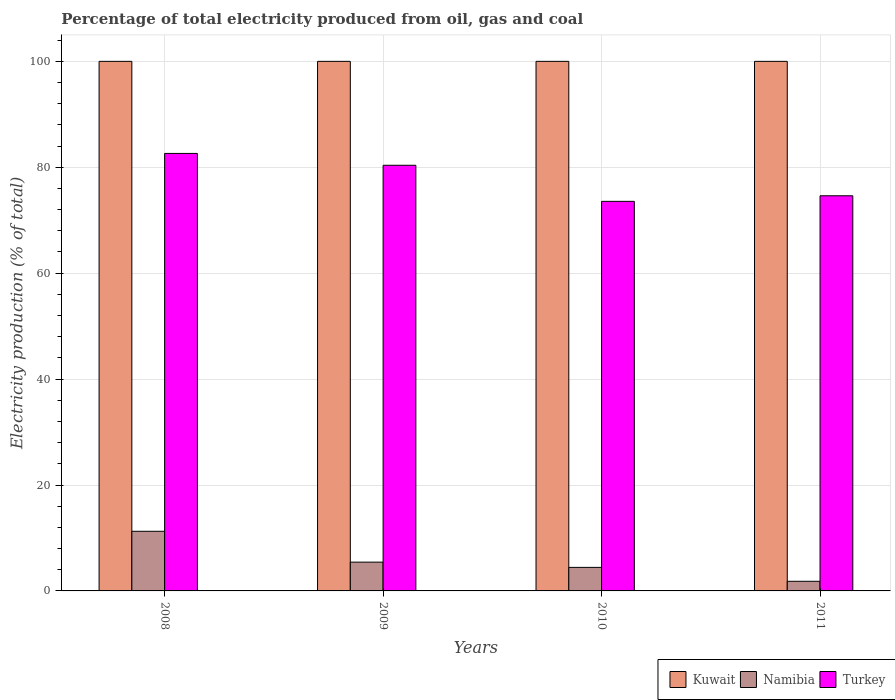How many groups of bars are there?
Give a very brief answer. 4. Are the number of bars per tick equal to the number of legend labels?
Make the answer very short. Yes. Are the number of bars on each tick of the X-axis equal?
Give a very brief answer. Yes. How many bars are there on the 3rd tick from the left?
Keep it short and to the point. 3. How many bars are there on the 2nd tick from the right?
Make the answer very short. 3. What is the label of the 1st group of bars from the left?
Offer a terse response. 2008. What is the electricity production in in Turkey in 2008?
Make the answer very short. 82.61. Across all years, what is the minimum electricity production in in Namibia?
Provide a succinct answer. 1.82. In which year was the electricity production in in Namibia minimum?
Your answer should be compact. 2011. What is the total electricity production in in Turkey in the graph?
Provide a succinct answer. 311.17. What is the difference between the electricity production in in Namibia in 2010 and that in 2011?
Ensure brevity in your answer.  2.63. What is the difference between the electricity production in in Turkey in 2011 and the electricity production in in Namibia in 2008?
Provide a short and direct response. 63.36. What is the average electricity production in in Turkey per year?
Ensure brevity in your answer.  77.79. In the year 2010, what is the difference between the electricity production in in Namibia and electricity production in in Kuwait?
Your answer should be compact. -95.56. In how many years, is the electricity production in in Turkey greater than 84 %?
Ensure brevity in your answer.  0. Is the electricity production in in Namibia in 2009 less than that in 2010?
Give a very brief answer. No. What is the difference between the highest and the second highest electricity production in in Kuwait?
Provide a succinct answer. 0. What is the difference between the highest and the lowest electricity production in in Turkey?
Your answer should be compact. 9.05. In how many years, is the electricity production in in Kuwait greater than the average electricity production in in Kuwait taken over all years?
Make the answer very short. 0. What does the 1st bar from the left in 2009 represents?
Offer a terse response. Kuwait. What does the 3rd bar from the right in 2008 represents?
Make the answer very short. Kuwait. Are all the bars in the graph horizontal?
Your response must be concise. No. What is the difference between two consecutive major ticks on the Y-axis?
Make the answer very short. 20. Are the values on the major ticks of Y-axis written in scientific E-notation?
Keep it short and to the point. No. Does the graph contain any zero values?
Make the answer very short. No. Does the graph contain grids?
Your answer should be very brief. Yes. Where does the legend appear in the graph?
Give a very brief answer. Bottom right. How many legend labels are there?
Your answer should be compact. 3. What is the title of the graph?
Give a very brief answer. Percentage of total electricity produced from oil, gas and coal. Does "Arab World" appear as one of the legend labels in the graph?
Offer a terse response. No. What is the label or title of the X-axis?
Your response must be concise. Years. What is the label or title of the Y-axis?
Provide a succinct answer. Electricity production (% of total). What is the Electricity production (% of total) in Namibia in 2008?
Offer a terse response. 11.26. What is the Electricity production (% of total) in Turkey in 2008?
Make the answer very short. 82.61. What is the Electricity production (% of total) in Kuwait in 2009?
Offer a very short reply. 100. What is the Electricity production (% of total) of Namibia in 2009?
Provide a succinct answer. 5.44. What is the Electricity production (% of total) in Turkey in 2009?
Provide a succinct answer. 80.38. What is the Electricity production (% of total) of Namibia in 2010?
Your answer should be compact. 4.44. What is the Electricity production (% of total) in Turkey in 2010?
Offer a very short reply. 73.56. What is the Electricity production (% of total) of Kuwait in 2011?
Ensure brevity in your answer.  100. What is the Electricity production (% of total) in Namibia in 2011?
Offer a very short reply. 1.82. What is the Electricity production (% of total) of Turkey in 2011?
Your answer should be compact. 74.62. Across all years, what is the maximum Electricity production (% of total) in Kuwait?
Give a very brief answer. 100. Across all years, what is the maximum Electricity production (% of total) of Namibia?
Make the answer very short. 11.26. Across all years, what is the maximum Electricity production (% of total) in Turkey?
Provide a short and direct response. 82.61. Across all years, what is the minimum Electricity production (% of total) in Namibia?
Provide a short and direct response. 1.82. Across all years, what is the minimum Electricity production (% of total) in Turkey?
Provide a short and direct response. 73.56. What is the total Electricity production (% of total) in Kuwait in the graph?
Give a very brief answer. 400. What is the total Electricity production (% of total) of Namibia in the graph?
Ensure brevity in your answer.  22.96. What is the total Electricity production (% of total) in Turkey in the graph?
Keep it short and to the point. 311.17. What is the difference between the Electricity production (% of total) in Kuwait in 2008 and that in 2009?
Your response must be concise. 0. What is the difference between the Electricity production (% of total) of Namibia in 2008 and that in 2009?
Make the answer very short. 5.82. What is the difference between the Electricity production (% of total) of Turkey in 2008 and that in 2009?
Provide a short and direct response. 2.24. What is the difference between the Electricity production (% of total) of Namibia in 2008 and that in 2010?
Make the answer very short. 6.82. What is the difference between the Electricity production (% of total) of Turkey in 2008 and that in 2010?
Offer a very short reply. 9.05. What is the difference between the Electricity production (% of total) of Namibia in 2008 and that in 2011?
Ensure brevity in your answer.  9.44. What is the difference between the Electricity production (% of total) of Turkey in 2008 and that in 2011?
Ensure brevity in your answer.  8. What is the difference between the Electricity production (% of total) in Kuwait in 2009 and that in 2010?
Offer a terse response. 0. What is the difference between the Electricity production (% of total) in Turkey in 2009 and that in 2010?
Offer a very short reply. 6.81. What is the difference between the Electricity production (% of total) of Kuwait in 2009 and that in 2011?
Offer a terse response. 0. What is the difference between the Electricity production (% of total) of Namibia in 2009 and that in 2011?
Offer a terse response. 3.62. What is the difference between the Electricity production (% of total) in Turkey in 2009 and that in 2011?
Your answer should be very brief. 5.76. What is the difference between the Electricity production (% of total) in Kuwait in 2010 and that in 2011?
Your response must be concise. 0. What is the difference between the Electricity production (% of total) in Namibia in 2010 and that in 2011?
Your response must be concise. 2.63. What is the difference between the Electricity production (% of total) in Turkey in 2010 and that in 2011?
Offer a very short reply. -1.06. What is the difference between the Electricity production (% of total) of Kuwait in 2008 and the Electricity production (% of total) of Namibia in 2009?
Provide a short and direct response. 94.56. What is the difference between the Electricity production (% of total) of Kuwait in 2008 and the Electricity production (% of total) of Turkey in 2009?
Your answer should be compact. 19.62. What is the difference between the Electricity production (% of total) in Namibia in 2008 and the Electricity production (% of total) in Turkey in 2009?
Keep it short and to the point. -69.12. What is the difference between the Electricity production (% of total) in Kuwait in 2008 and the Electricity production (% of total) in Namibia in 2010?
Your response must be concise. 95.56. What is the difference between the Electricity production (% of total) in Kuwait in 2008 and the Electricity production (% of total) in Turkey in 2010?
Provide a succinct answer. 26.44. What is the difference between the Electricity production (% of total) in Namibia in 2008 and the Electricity production (% of total) in Turkey in 2010?
Make the answer very short. -62.3. What is the difference between the Electricity production (% of total) in Kuwait in 2008 and the Electricity production (% of total) in Namibia in 2011?
Give a very brief answer. 98.18. What is the difference between the Electricity production (% of total) in Kuwait in 2008 and the Electricity production (% of total) in Turkey in 2011?
Provide a succinct answer. 25.38. What is the difference between the Electricity production (% of total) in Namibia in 2008 and the Electricity production (% of total) in Turkey in 2011?
Your response must be concise. -63.36. What is the difference between the Electricity production (% of total) of Kuwait in 2009 and the Electricity production (% of total) of Namibia in 2010?
Provide a succinct answer. 95.56. What is the difference between the Electricity production (% of total) in Kuwait in 2009 and the Electricity production (% of total) in Turkey in 2010?
Offer a very short reply. 26.44. What is the difference between the Electricity production (% of total) of Namibia in 2009 and the Electricity production (% of total) of Turkey in 2010?
Offer a terse response. -68.13. What is the difference between the Electricity production (% of total) in Kuwait in 2009 and the Electricity production (% of total) in Namibia in 2011?
Provide a short and direct response. 98.18. What is the difference between the Electricity production (% of total) in Kuwait in 2009 and the Electricity production (% of total) in Turkey in 2011?
Keep it short and to the point. 25.38. What is the difference between the Electricity production (% of total) of Namibia in 2009 and the Electricity production (% of total) of Turkey in 2011?
Give a very brief answer. -69.18. What is the difference between the Electricity production (% of total) of Kuwait in 2010 and the Electricity production (% of total) of Namibia in 2011?
Ensure brevity in your answer.  98.18. What is the difference between the Electricity production (% of total) in Kuwait in 2010 and the Electricity production (% of total) in Turkey in 2011?
Offer a terse response. 25.38. What is the difference between the Electricity production (% of total) of Namibia in 2010 and the Electricity production (% of total) of Turkey in 2011?
Give a very brief answer. -70.17. What is the average Electricity production (% of total) of Namibia per year?
Offer a very short reply. 5.74. What is the average Electricity production (% of total) of Turkey per year?
Ensure brevity in your answer.  77.79. In the year 2008, what is the difference between the Electricity production (% of total) in Kuwait and Electricity production (% of total) in Namibia?
Provide a succinct answer. 88.74. In the year 2008, what is the difference between the Electricity production (% of total) in Kuwait and Electricity production (% of total) in Turkey?
Give a very brief answer. 17.39. In the year 2008, what is the difference between the Electricity production (% of total) of Namibia and Electricity production (% of total) of Turkey?
Keep it short and to the point. -71.35. In the year 2009, what is the difference between the Electricity production (% of total) of Kuwait and Electricity production (% of total) of Namibia?
Your answer should be very brief. 94.56. In the year 2009, what is the difference between the Electricity production (% of total) in Kuwait and Electricity production (% of total) in Turkey?
Keep it short and to the point. 19.62. In the year 2009, what is the difference between the Electricity production (% of total) of Namibia and Electricity production (% of total) of Turkey?
Ensure brevity in your answer.  -74.94. In the year 2010, what is the difference between the Electricity production (% of total) of Kuwait and Electricity production (% of total) of Namibia?
Your answer should be very brief. 95.56. In the year 2010, what is the difference between the Electricity production (% of total) in Kuwait and Electricity production (% of total) in Turkey?
Your answer should be compact. 26.44. In the year 2010, what is the difference between the Electricity production (% of total) of Namibia and Electricity production (% of total) of Turkey?
Your response must be concise. -69.12. In the year 2011, what is the difference between the Electricity production (% of total) of Kuwait and Electricity production (% of total) of Namibia?
Provide a short and direct response. 98.18. In the year 2011, what is the difference between the Electricity production (% of total) of Kuwait and Electricity production (% of total) of Turkey?
Offer a terse response. 25.38. In the year 2011, what is the difference between the Electricity production (% of total) of Namibia and Electricity production (% of total) of Turkey?
Your answer should be very brief. -72.8. What is the ratio of the Electricity production (% of total) in Namibia in 2008 to that in 2009?
Provide a short and direct response. 2.07. What is the ratio of the Electricity production (% of total) in Turkey in 2008 to that in 2009?
Provide a succinct answer. 1.03. What is the ratio of the Electricity production (% of total) of Namibia in 2008 to that in 2010?
Make the answer very short. 2.53. What is the ratio of the Electricity production (% of total) of Turkey in 2008 to that in 2010?
Offer a terse response. 1.12. What is the ratio of the Electricity production (% of total) in Kuwait in 2008 to that in 2011?
Your response must be concise. 1. What is the ratio of the Electricity production (% of total) of Namibia in 2008 to that in 2011?
Keep it short and to the point. 6.19. What is the ratio of the Electricity production (% of total) in Turkey in 2008 to that in 2011?
Offer a terse response. 1.11. What is the ratio of the Electricity production (% of total) in Kuwait in 2009 to that in 2010?
Make the answer very short. 1. What is the ratio of the Electricity production (% of total) in Namibia in 2009 to that in 2010?
Offer a very short reply. 1.22. What is the ratio of the Electricity production (% of total) in Turkey in 2009 to that in 2010?
Offer a very short reply. 1.09. What is the ratio of the Electricity production (% of total) of Kuwait in 2009 to that in 2011?
Your answer should be very brief. 1. What is the ratio of the Electricity production (% of total) in Namibia in 2009 to that in 2011?
Your answer should be compact. 2.99. What is the ratio of the Electricity production (% of total) in Turkey in 2009 to that in 2011?
Make the answer very short. 1.08. What is the ratio of the Electricity production (% of total) of Namibia in 2010 to that in 2011?
Offer a terse response. 2.44. What is the ratio of the Electricity production (% of total) of Turkey in 2010 to that in 2011?
Make the answer very short. 0.99. What is the difference between the highest and the second highest Electricity production (% of total) in Namibia?
Offer a very short reply. 5.82. What is the difference between the highest and the second highest Electricity production (% of total) of Turkey?
Provide a succinct answer. 2.24. What is the difference between the highest and the lowest Electricity production (% of total) of Namibia?
Provide a short and direct response. 9.44. What is the difference between the highest and the lowest Electricity production (% of total) of Turkey?
Make the answer very short. 9.05. 